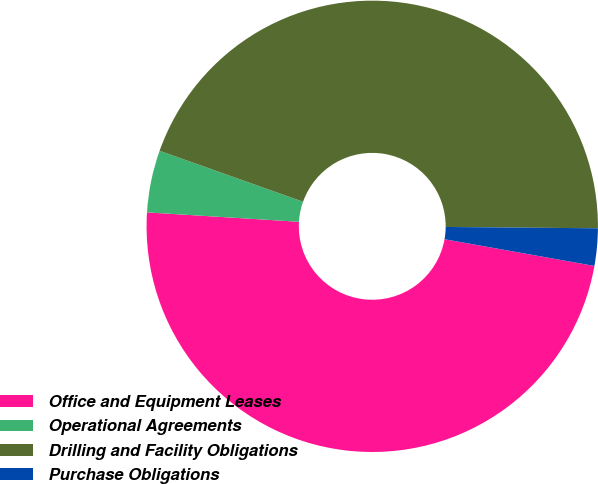Convert chart. <chart><loc_0><loc_0><loc_500><loc_500><pie_chart><fcel>Office and Equipment Leases<fcel>Operational Agreements<fcel>Drilling and Facility Obligations<fcel>Purchase Obligations<nl><fcel>48.18%<fcel>4.45%<fcel>44.71%<fcel>2.67%<nl></chart> 